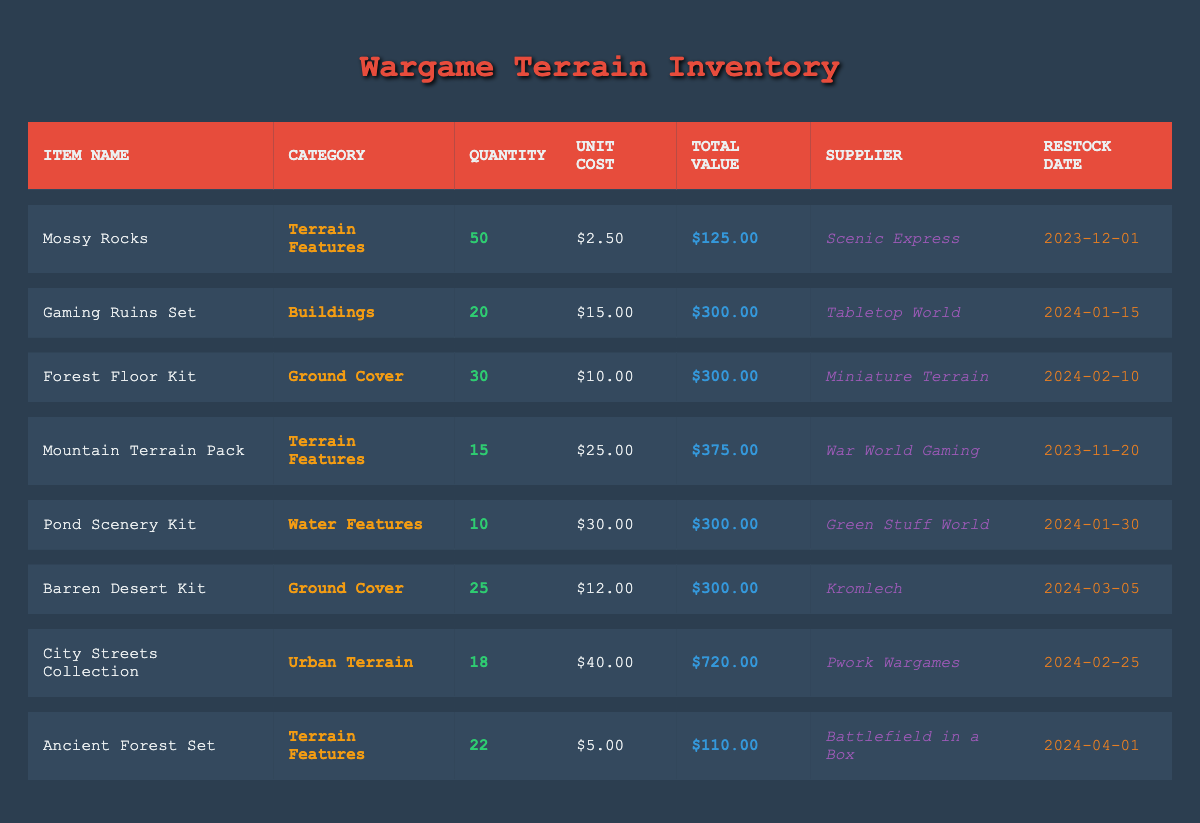What is the unit cost of the "Mountain Terrain Pack"? The table lists the "Mountain Terrain Pack" under item name, where the unit cost is specified in the same row. By looking at that row, we find the unit cost is $25.00.
Answer: $25.00 How many "Pond Scenery Kits" are available in stock? The row for "Pond Scenery Kit" indicates that there are 10 units available. This value is directly stated in the quantity column of that specific row.
Answer: 10 What is the total value of all the "Ground Cover" items in the inventory? The two entries listed as "Ground Cover" are the "Forest Floor Kit" (total value $300.00) and "Barren Desert Kit" (total value $300.00). Adding both totals gives $300.00 + $300.00 = $600.00.
Answer: $600.00 Is there a "Water Features" item that has a quantity greater than 5? The "Pond Scenery Kit" under the "Water Features" category has a quantity of 10, which is greater than 5. This is confirmed by checking the quantity column of that entry.
Answer: Yes What supplier provides the "Gaming Ruins Set"? In the inventory table, the entry for "Gaming Ruins Set" shows that its supplier is "Tabletop World." This information is directly provided in the corresponding row.
Answer: Tabletop World How many items are there in the "Terrain Features" category? There are three entries in the "Terrain Features" category: "Mossy Rocks," "Mountain Terrain Pack," and "Ancient Forest Set." Counting these entries gives a total of 3 items.
Answer: 3 What is the average total value of items supplied by "Green Stuff World" and "Kromlech"? The "Pond Scenery Kit" from "Green Stuff World" is valued at $300.00, and the "Barren Desert Kit" from "Kromlech" is also valued at $300.00. The average is calculated by summing the total values: $300.00 + $300.00 = $600.00, then dividing by 2, which gives $600.00 / 2 = $300.00.
Answer: $300.00 Which item has the latest restock date? Reviewing the restock dates, "Ancient Forest Set" is scheduled to be restocked on 2024-04-01 while the latest among the rest of is 2024-03-05 for the "Barren Desert Kit." The latest is thus on 2024-04-01.
Answer: 2024-04-01 How many total units of all "Urban Terrain" items do we have? The only entry in the "Urban Terrain" category is "City Streets Collection," with a quantity of 18, so the total units for that category is simply 18.
Answer: 18 